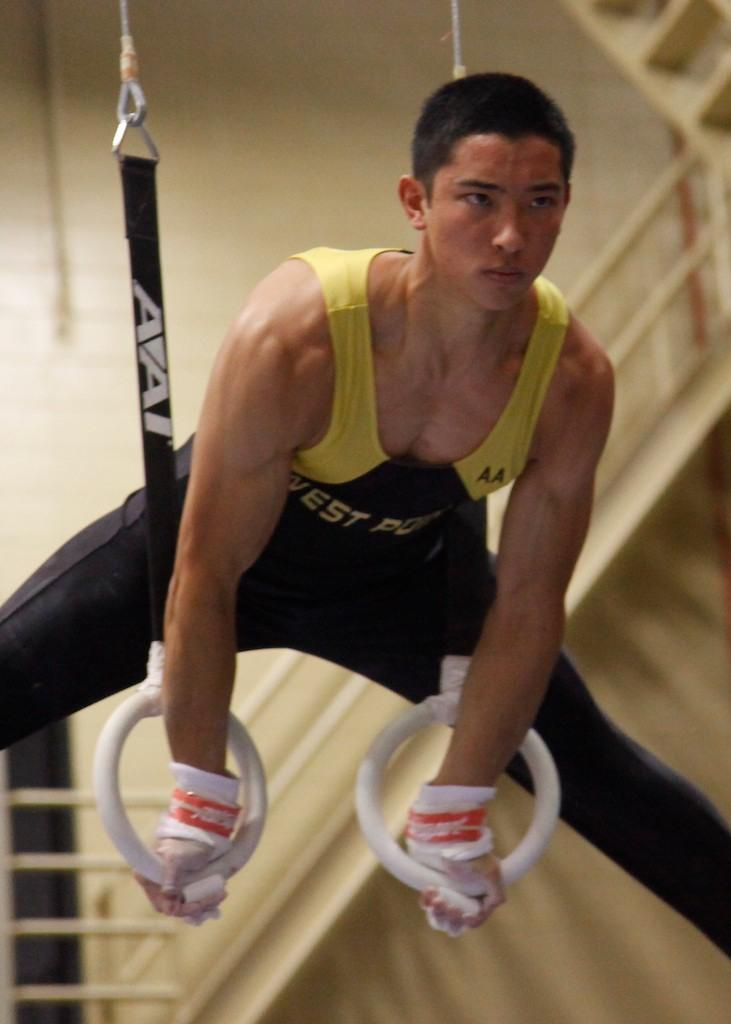<image>
Offer a succinct explanation of the picture presented. A gymnast is exercising on rings, which were manufactured by AAI. 